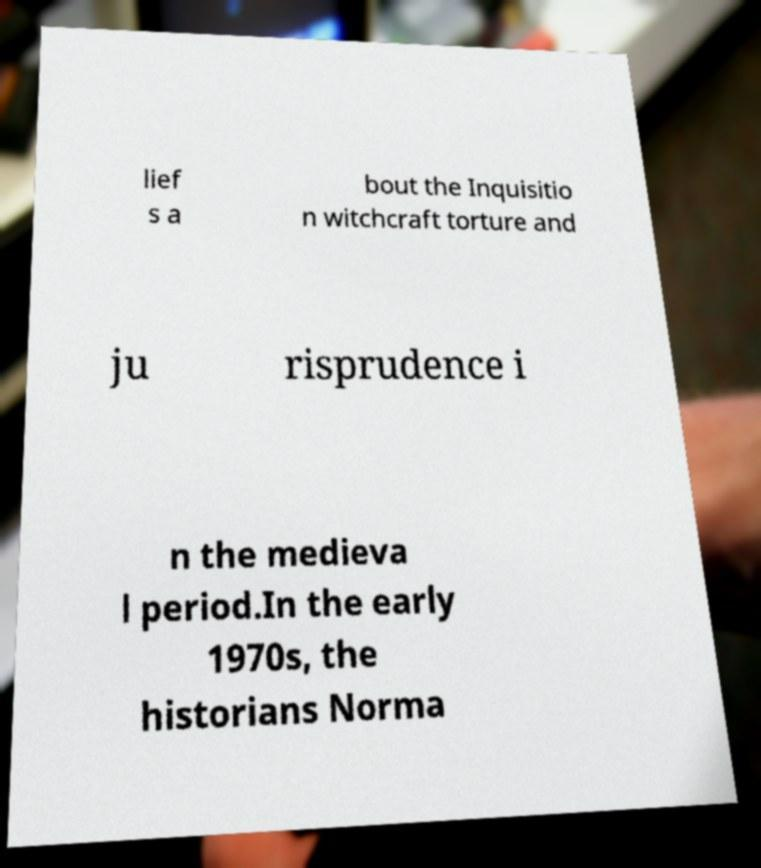There's text embedded in this image that I need extracted. Can you transcribe it verbatim? lief s a bout the Inquisitio n witchcraft torture and ju risprudence i n the medieva l period.In the early 1970s, the historians Norma 